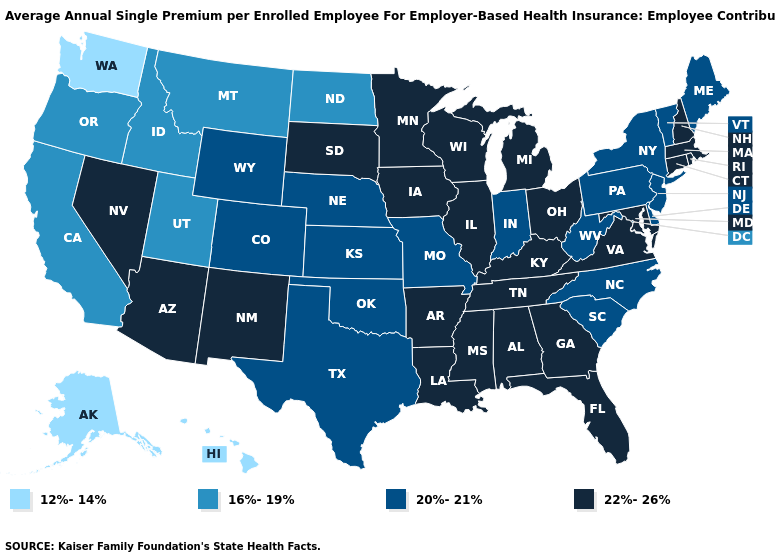What is the value of Minnesota?
Concise answer only. 22%-26%. What is the value of South Carolina?
Short answer required. 20%-21%. Name the states that have a value in the range 16%-19%?
Write a very short answer. California, Idaho, Montana, North Dakota, Oregon, Utah. Among the states that border South Dakota , which have the lowest value?
Write a very short answer. Montana, North Dakota. What is the value of New York?
Concise answer only. 20%-21%. Does Alaska have a higher value than Connecticut?
Answer briefly. No. What is the lowest value in the West?
Be succinct. 12%-14%. Does New Mexico have the same value as Idaho?
Short answer required. No. Does the map have missing data?
Answer briefly. No. What is the value of New Jersey?
Give a very brief answer. 20%-21%. What is the highest value in states that border New Jersey?
Quick response, please. 20%-21%. Among the states that border New Jersey , which have the lowest value?
Keep it brief. Delaware, New York, Pennsylvania. Which states have the highest value in the USA?
Write a very short answer. Alabama, Arizona, Arkansas, Connecticut, Florida, Georgia, Illinois, Iowa, Kentucky, Louisiana, Maryland, Massachusetts, Michigan, Minnesota, Mississippi, Nevada, New Hampshire, New Mexico, Ohio, Rhode Island, South Dakota, Tennessee, Virginia, Wisconsin. What is the lowest value in the MidWest?
Keep it brief. 16%-19%. Name the states that have a value in the range 22%-26%?
Be succinct. Alabama, Arizona, Arkansas, Connecticut, Florida, Georgia, Illinois, Iowa, Kentucky, Louisiana, Maryland, Massachusetts, Michigan, Minnesota, Mississippi, Nevada, New Hampshire, New Mexico, Ohio, Rhode Island, South Dakota, Tennessee, Virginia, Wisconsin. 